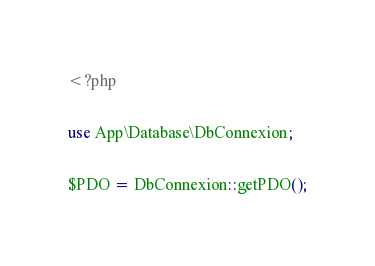Convert code to text. <code><loc_0><loc_0><loc_500><loc_500><_PHP_><?php

use App\Database\DbConnexion;

$PDO = DbConnexion::getPDO();
</code> 